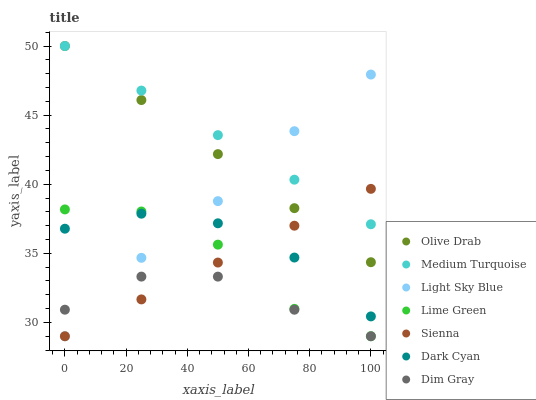Does Dim Gray have the minimum area under the curve?
Answer yes or no. Yes. Does Medium Turquoise have the maximum area under the curve?
Answer yes or no. Yes. Does Sienna have the minimum area under the curve?
Answer yes or no. No. Does Sienna have the maximum area under the curve?
Answer yes or no. No. Is Medium Turquoise the smoothest?
Answer yes or no. Yes. Is Lime Green the roughest?
Answer yes or no. Yes. Is Sienna the smoothest?
Answer yes or no. No. Is Sienna the roughest?
Answer yes or no. No. Does Dim Gray have the lowest value?
Answer yes or no. Yes. Does Medium Turquoise have the lowest value?
Answer yes or no. No. Does Olive Drab have the highest value?
Answer yes or no. Yes. Does Sienna have the highest value?
Answer yes or no. No. Is Lime Green less than Olive Drab?
Answer yes or no. Yes. Is Olive Drab greater than Dark Cyan?
Answer yes or no. Yes. Does Sienna intersect Lime Green?
Answer yes or no. Yes. Is Sienna less than Lime Green?
Answer yes or no. No. Is Sienna greater than Lime Green?
Answer yes or no. No. Does Lime Green intersect Olive Drab?
Answer yes or no. No. 